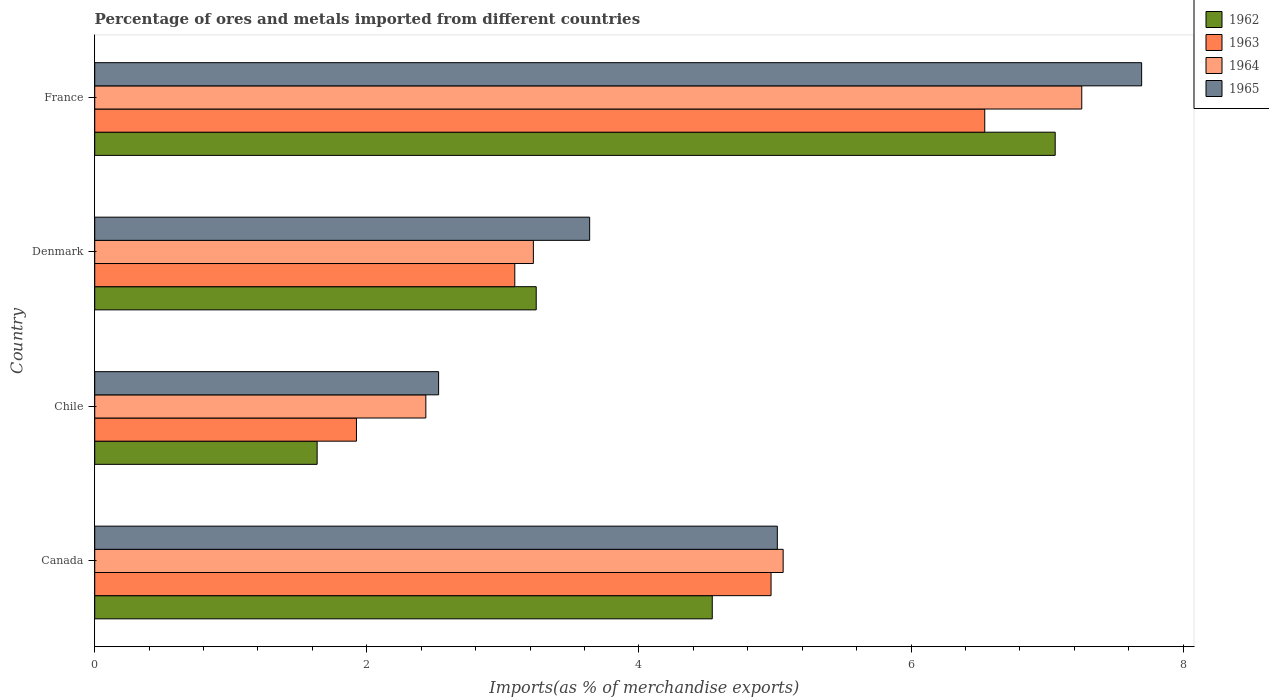How many different coloured bars are there?
Make the answer very short. 4. How many groups of bars are there?
Keep it short and to the point. 4. Are the number of bars per tick equal to the number of legend labels?
Offer a terse response. Yes. Are the number of bars on each tick of the Y-axis equal?
Offer a very short reply. Yes. How many bars are there on the 2nd tick from the top?
Your answer should be very brief. 4. What is the percentage of imports to different countries in 1963 in Denmark?
Give a very brief answer. 3.09. Across all countries, what is the maximum percentage of imports to different countries in 1962?
Your response must be concise. 7.06. Across all countries, what is the minimum percentage of imports to different countries in 1963?
Your answer should be very brief. 1.92. In which country was the percentage of imports to different countries in 1962 minimum?
Offer a terse response. Chile. What is the total percentage of imports to different countries in 1965 in the graph?
Make the answer very short. 18.88. What is the difference between the percentage of imports to different countries in 1964 in Chile and that in Denmark?
Keep it short and to the point. -0.79. What is the difference between the percentage of imports to different countries in 1962 in Chile and the percentage of imports to different countries in 1963 in Denmark?
Provide a short and direct response. -1.45. What is the average percentage of imports to different countries in 1963 per country?
Give a very brief answer. 4.13. What is the difference between the percentage of imports to different countries in 1964 and percentage of imports to different countries in 1965 in Canada?
Your answer should be very brief. 0.04. What is the ratio of the percentage of imports to different countries in 1965 in Canada to that in France?
Provide a short and direct response. 0.65. Is the percentage of imports to different countries in 1964 in Canada less than that in France?
Offer a terse response. Yes. What is the difference between the highest and the second highest percentage of imports to different countries in 1962?
Provide a short and direct response. 2.52. What is the difference between the highest and the lowest percentage of imports to different countries in 1963?
Give a very brief answer. 4.62. What does the 1st bar from the bottom in Canada represents?
Keep it short and to the point. 1962. Are all the bars in the graph horizontal?
Your answer should be very brief. Yes. Are the values on the major ticks of X-axis written in scientific E-notation?
Provide a succinct answer. No. What is the title of the graph?
Make the answer very short. Percentage of ores and metals imported from different countries. What is the label or title of the X-axis?
Provide a succinct answer. Imports(as % of merchandise exports). What is the label or title of the Y-axis?
Keep it short and to the point. Country. What is the Imports(as % of merchandise exports) in 1962 in Canada?
Offer a terse response. 4.54. What is the Imports(as % of merchandise exports) of 1963 in Canada?
Keep it short and to the point. 4.97. What is the Imports(as % of merchandise exports) of 1964 in Canada?
Offer a very short reply. 5.06. What is the Imports(as % of merchandise exports) of 1965 in Canada?
Keep it short and to the point. 5.02. What is the Imports(as % of merchandise exports) of 1962 in Chile?
Give a very brief answer. 1.63. What is the Imports(as % of merchandise exports) in 1963 in Chile?
Keep it short and to the point. 1.92. What is the Imports(as % of merchandise exports) in 1964 in Chile?
Your response must be concise. 2.43. What is the Imports(as % of merchandise exports) of 1965 in Chile?
Make the answer very short. 2.53. What is the Imports(as % of merchandise exports) in 1962 in Denmark?
Keep it short and to the point. 3.25. What is the Imports(as % of merchandise exports) in 1963 in Denmark?
Give a very brief answer. 3.09. What is the Imports(as % of merchandise exports) in 1964 in Denmark?
Your response must be concise. 3.22. What is the Imports(as % of merchandise exports) of 1965 in Denmark?
Your answer should be compact. 3.64. What is the Imports(as % of merchandise exports) in 1962 in France?
Keep it short and to the point. 7.06. What is the Imports(as % of merchandise exports) of 1963 in France?
Offer a very short reply. 6.54. What is the Imports(as % of merchandise exports) in 1964 in France?
Ensure brevity in your answer.  7.26. What is the Imports(as % of merchandise exports) in 1965 in France?
Provide a succinct answer. 7.7. Across all countries, what is the maximum Imports(as % of merchandise exports) in 1962?
Your response must be concise. 7.06. Across all countries, what is the maximum Imports(as % of merchandise exports) of 1963?
Your response must be concise. 6.54. Across all countries, what is the maximum Imports(as % of merchandise exports) of 1964?
Your answer should be compact. 7.26. Across all countries, what is the maximum Imports(as % of merchandise exports) in 1965?
Make the answer very short. 7.7. Across all countries, what is the minimum Imports(as % of merchandise exports) of 1962?
Provide a succinct answer. 1.63. Across all countries, what is the minimum Imports(as % of merchandise exports) of 1963?
Give a very brief answer. 1.92. Across all countries, what is the minimum Imports(as % of merchandise exports) of 1964?
Provide a short and direct response. 2.43. Across all countries, what is the minimum Imports(as % of merchandise exports) of 1965?
Offer a very short reply. 2.53. What is the total Imports(as % of merchandise exports) in 1962 in the graph?
Provide a short and direct response. 16.48. What is the total Imports(as % of merchandise exports) in 1963 in the graph?
Make the answer very short. 16.52. What is the total Imports(as % of merchandise exports) of 1964 in the graph?
Provide a short and direct response. 17.97. What is the total Imports(as % of merchandise exports) in 1965 in the graph?
Your answer should be very brief. 18.88. What is the difference between the Imports(as % of merchandise exports) of 1962 in Canada and that in Chile?
Keep it short and to the point. 2.9. What is the difference between the Imports(as % of merchandise exports) in 1963 in Canada and that in Chile?
Your answer should be very brief. 3.05. What is the difference between the Imports(as % of merchandise exports) of 1964 in Canada and that in Chile?
Offer a terse response. 2.63. What is the difference between the Imports(as % of merchandise exports) in 1965 in Canada and that in Chile?
Your answer should be very brief. 2.49. What is the difference between the Imports(as % of merchandise exports) in 1962 in Canada and that in Denmark?
Provide a succinct answer. 1.29. What is the difference between the Imports(as % of merchandise exports) of 1963 in Canada and that in Denmark?
Provide a succinct answer. 1.88. What is the difference between the Imports(as % of merchandise exports) of 1964 in Canada and that in Denmark?
Your response must be concise. 1.84. What is the difference between the Imports(as % of merchandise exports) in 1965 in Canada and that in Denmark?
Provide a succinct answer. 1.38. What is the difference between the Imports(as % of merchandise exports) in 1962 in Canada and that in France?
Give a very brief answer. -2.52. What is the difference between the Imports(as % of merchandise exports) of 1963 in Canada and that in France?
Offer a terse response. -1.57. What is the difference between the Imports(as % of merchandise exports) in 1964 in Canada and that in France?
Ensure brevity in your answer.  -2.19. What is the difference between the Imports(as % of merchandise exports) in 1965 in Canada and that in France?
Provide a short and direct response. -2.68. What is the difference between the Imports(as % of merchandise exports) in 1962 in Chile and that in Denmark?
Give a very brief answer. -1.61. What is the difference between the Imports(as % of merchandise exports) of 1963 in Chile and that in Denmark?
Ensure brevity in your answer.  -1.16. What is the difference between the Imports(as % of merchandise exports) in 1964 in Chile and that in Denmark?
Ensure brevity in your answer.  -0.79. What is the difference between the Imports(as % of merchandise exports) in 1965 in Chile and that in Denmark?
Give a very brief answer. -1.11. What is the difference between the Imports(as % of merchandise exports) in 1962 in Chile and that in France?
Ensure brevity in your answer.  -5.43. What is the difference between the Imports(as % of merchandise exports) of 1963 in Chile and that in France?
Your answer should be compact. -4.62. What is the difference between the Imports(as % of merchandise exports) of 1964 in Chile and that in France?
Give a very brief answer. -4.82. What is the difference between the Imports(as % of merchandise exports) of 1965 in Chile and that in France?
Your answer should be very brief. -5.17. What is the difference between the Imports(as % of merchandise exports) in 1962 in Denmark and that in France?
Ensure brevity in your answer.  -3.81. What is the difference between the Imports(as % of merchandise exports) of 1963 in Denmark and that in France?
Offer a terse response. -3.45. What is the difference between the Imports(as % of merchandise exports) in 1964 in Denmark and that in France?
Give a very brief answer. -4.03. What is the difference between the Imports(as % of merchandise exports) of 1965 in Denmark and that in France?
Give a very brief answer. -4.06. What is the difference between the Imports(as % of merchandise exports) in 1962 in Canada and the Imports(as % of merchandise exports) in 1963 in Chile?
Offer a very short reply. 2.62. What is the difference between the Imports(as % of merchandise exports) in 1962 in Canada and the Imports(as % of merchandise exports) in 1964 in Chile?
Your answer should be compact. 2.11. What is the difference between the Imports(as % of merchandise exports) in 1962 in Canada and the Imports(as % of merchandise exports) in 1965 in Chile?
Make the answer very short. 2.01. What is the difference between the Imports(as % of merchandise exports) of 1963 in Canada and the Imports(as % of merchandise exports) of 1964 in Chile?
Make the answer very short. 2.54. What is the difference between the Imports(as % of merchandise exports) of 1963 in Canada and the Imports(as % of merchandise exports) of 1965 in Chile?
Make the answer very short. 2.44. What is the difference between the Imports(as % of merchandise exports) of 1964 in Canada and the Imports(as % of merchandise exports) of 1965 in Chile?
Your answer should be compact. 2.53. What is the difference between the Imports(as % of merchandise exports) of 1962 in Canada and the Imports(as % of merchandise exports) of 1963 in Denmark?
Offer a terse response. 1.45. What is the difference between the Imports(as % of merchandise exports) of 1962 in Canada and the Imports(as % of merchandise exports) of 1964 in Denmark?
Keep it short and to the point. 1.31. What is the difference between the Imports(as % of merchandise exports) of 1962 in Canada and the Imports(as % of merchandise exports) of 1965 in Denmark?
Give a very brief answer. 0.9. What is the difference between the Imports(as % of merchandise exports) in 1963 in Canada and the Imports(as % of merchandise exports) in 1964 in Denmark?
Make the answer very short. 1.75. What is the difference between the Imports(as % of merchandise exports) of 1963 in Canada and the Imports(as % of merchandise exports) of 1965 in Denmark?
Make the answer very short. 1.33. What is the difference between the Imports(as % of merchandise exports) in 1964 in Canada and the Imports(as % of merchandise exports) in 1965 in Denmark?
Offer a very short reply. 1.42. What is the difference between the Imports(as % of merchandise exports) in 1962 in Canada and the Imports(as % of merchandise exports) in 1963 in France?
Provide a short and direct response. -2. What is the difference between the Imports(as % of merchandise exports) in 1962 in Canada and the Imports(as % of merchandise exports) in 1964 in France?
Ensure brevity in your answer.  -2.72. What is the difference between the Imports(as % of merchandise exports) of 1962 in Canada and the Imports(as % of merchandise exports) of 1965 in France?
Make the answer very short. -3.16. What is the difference between the Imports(as % of merchandise exports) in 1963 in Canada and the Imports(as % of merchandise exports) in 1964 in France?
Provide a short and direct response. -2.28. What is the difference between the Imports(as % of merchandise exports) of 1963 in Canada and the Imports(as % of merchandise exports) of 1965 in France?
Keep it short and to the point. -2.72. What is the difference between the Imports(as % of merchandise exports) in 1964 in Canada and the Imports(as % of merchandise exports) in 1965 in France?
Your answer should be very brief. -2.64. What is the difference between the Imports(as % of merchandise exports) in 1962 in Chile and the Imports(as % of merchandise exports) in 1963 in Denmark?
Give a very brief answer. -1.45. What is the difference between the Imports(as % of merchandise exports) of 1962 in Chile and the Imports(as % of merchandise exports) of 1964 in Denmark?
Your response must be concise. -1.59. What is the difference between the Imports(as % of merchandise exports) in 1962 in Chile and the Imports(as % of merchandise exports) in 1965 in Denmark?
Give a very brief answer. -2. What is the difference between the Imports(as % of merchandise exports) of 1963 in Chile and the Imports(as % of merchandise exports) of 1964 in Denmark?
Give a very brief answer. -1.3. What is the difference between the Imports(as % of merchandise exports) of 1963 in Chile and the Imports(as % of merchandise exports) of 1965 in Denmark?
Your response must be concise. -1.71. What is the difference between the Imports(as % of merchandise exports) of 1964 in Chile and the Imports(as % of merchandise exports) of 1965 in Denmark?
Offer a terse response. -1.2. What is the difference between the Imports(as % of merchandise exports) in 1962 in Chile and the Imports(as % of merchandise exports) in 1963 in France?
Provide a short and direct response. -4.91. What is the difference between the Imports(as % of merchandise exports) in 1962 in Chile and the Imports(as % of merchandise exports) in 1964 in France?
Provide a succinct answer. -5.62. What is the difference between the Imports(as % of merchandise exports) in 1962 in Chile and the Imports(as % of merchandise exports) in 1965 in France?
Offer a very short reply. -6.06. What is the difference between the Imports(as % of merchandise exports) in 1963 in Chile and the Imports(as % of merchandise exports) in 1964 in France?
Offer a very short reply. -5.33. What is the difference between the Imports(as % of merchandise exports) in 1963 in Chile and the Imports(as % of merchandise exports) in 1965 in France?
Keep it short and to the point. -5.77. What is the difference between the Imports(as % of merchandise exports) in 1964 in Chile and the Imports(as % of merchandise exports) in 1965 in France?
Make the answer very short. -5.26. What is the difference between the Imports(as % of merchandise exports) of 1962 in Denmark and the Imports(as % of merchandise exports) of 1963 in France?
Provide a succinct answer. -3.3. What is the difference between the Imports(as % of merchandise exports) of 1962 in Denmark and the Imports(as % of merchandise exports) of 1964 in France?
Provide a short and direct response. -4.01. What is the difference between the Imports(as % of merchandise exports) in 1962 in Denmark and the Imports(as % of merchandise exports) in 1965 in France?
Ensure brevity in your answer.  -4.45. What is the difference between the Imports(as % of merchandise exports) in 1963 in Denmark and the Imports(as % of merchandise exports) in 1964 in France?
Keep it short and to the point. -4.17. What is the difference between the Imports(as % of merchandise exports) in 1963 in Denmark and the Imports(as % of merchandise exports) in 1965 in France?
Provide a short and direct response. -4.61. What is the difference between the Imports(as % of merchandise exports) of 1964 in Denmark and the Imports(as % of merchandise exports) of 1965 in France?
Ensure brevity in your answer.  -4.47. What is the average Imports(as % of merchandise exports) in 1962 per country?
Your answer should be very brief. 4.12. What is the average Imports(as % of merchandise exports) of 1963 per country?
Provide a short and direct response. 4.13. What is the average Imports(as % of merchandise exports) of 1964 per country?
Ensure brevity in your answer.  4.49. What is the average Imports(as % of merchandise exports) of 1965 per country?
Your answer should be compact. 4.72. What is the difference between the Imports(as % of merchandise exports) of 1962 and Imports(as % of merchandise exports) of 1963 in Canada?
Give a very brief answer. -0.43. What is the difference between the Imports(as % of merchandise exports) of 1962 and Imports(as % of merchandise exports) of 1964 in Canada?
Your answer should be compact. -0.52. What is the difference between the Imports(as % of merchandise exports) in 1962 and Imports(as % of merchandise exports) in 1965 in Canada?
Keep it short and to the point. -0.48. What is the difference between the Imports(as % of merchandise exports) in 1963 and Imports(as % of merchandise exports) in 1964 in Canada?
Provide a succinct answer. -0.09. What is the difference between the Imports(as % of merchandise exports) in 1963 and Imports(as % of merchandise exports) in 1965 in Canada?
Give a very brief answer. -0.05. What is the difference between the Imports(as % of merchandise exports) in 1964 and Imports(as % of merchandise exports) in 1965 in Canada?
Provide a short and direct response. 0.04. What is the difference between the Imports(as % of merchandise exports) of 1962 and Imports(as % of merchandise exports) of 1963 in Chile?
Keep it short and to the point. -0.29. What is the difference between the Imports(as % of merchandise exports) in 1962 and Imports(as % of merchandise exports) in 1964 in Chile?
Keep it short and to the point. -0.8. What is the difference between the Imports(as % of merchandise exports) of 1962 and Imports(as % of merchandise exports) of 1965 in Chile?
Ensure brevity in your answer.  -0.89. What is the difference between the Imports(as % of merchandise exports) of 1963 and Imports(as % of merchandise exports) of 1964 in Chile?
Offer a very short reply. -0.51. What is the difference between the Imports(as % of merchandise exports) in 1963 and Imports(as % of merchandise exports) in 1965 in Chile?
Your answer should be very brief. -0.6. What is the difference between the Imports(as % of merchandise exports) of 1964 and Imports(as % of merchandise exports) of 1965 in Chile?
Provide a succinct answer. -0.09. What is the difference between the Imports(as % of merchandise exports) in 1962 and Imports(as % of merchandise exports) in 1963 in Denmark?
Offer a terse response. 0.16. What is the difference between the Imports(as % of merchandise exports) in 1962 and Imports(as % of merchandise exports) in 1964 in Denmark?
Your answer should be very brief. 0.02. What is the difference between the Imports(as % of merchandise exports) in 1962 and Imports(as % of merchandise exports) in 1965 in Denmark?
Offer a terse response. -0.39. What is the difference between the Imports(as % of merchandise exports) in 1963 and Imports(as % of merchandise exports) in 1964 in Denmark?
Offer a very short reply. -0.14. What is the difference between the Imports(as % of merchandise exports) of 1963 and Imports(as % of merchandise exports) of 1965 in Denmark?
Give a very brief answer. -0.55. What is the difference between the Imports(as % of merchandise exports) of 1964 and Imports(as % of merchandise exports) of 1965 in Denmark?
Your answer should be compact. -0.41. What is the difference between the Imports(as % of merchandise exports) in 1962 and Imports(as % of merchandise exports) in 1963 in France?
Provide a succinct answer. 0.52. What is the difference between the Imports(as % of merchandise exports) in 1962 and Imports(as % of merchandise exports) in 1964 in France?
Keep it short and to the point. -0.2. What is the difference between the Imports(as % of merchandise exports) in 1962 and Imports(as % of merchandise exports) in 1965 in France?
Keep it short and to the point. -0.64. What is the difference between the Imports(as % of merchandise exports) of 1963 and Imports(as % of merchandise exports) of 1964 in France?
Offer a terse response. -0.71. What is the difference between the Imports(as % of merchandise exports) of 1963 and Imports(as % of merchandise exports) of 1965 in France?
Ensure brevity in your answer.  -1.15. What is the difference between the Imports(as % of merchandise exports) in 1964 and Imports(as % of merchandise exports) in 1965 in France?
Give a very brief answer. -0.44. What is the ratio of the Imports(as % of merchandise exports) of 1962 in Canada to that in Chile?
Provide a succinct answer. 2.78. What is the ratio of the Imports(as % of merchandise exports) in 1963 in Canada to that in Chile?
Offer a terse response. 2.58. What is the ratio of the Imports(as % of merchandise exports) of 1964 in Canada to that in Chile?
Provide a short and direct response. 2.08. What is the ratio of the Imports(as % of merchandise exports) of 1965 in Canada to that in Chile?
Provide a succinct answer. 1.99. What is the ratio of the Imports(as % of merchandise exports) of 1962 in Canada to that in Denmark?
Ensure brevity in your answer.  1.4. What is the ratio of the Imports(as % of merchandise exports) in 1963 in Canada to that in Denmark?
Keep it short and to the point. 1.61. What is the ratio of the Imports(as % of merchandise exports) in 1964 in Canada to that in Denmark?
Provide a succinct answer. 1.57. What is the ratio of the Imports(as % of merchandise exports) of 1965 in Canada to that in Denmark?
Ensure brevity in your answer.  1.38. What is the ratio of the Imports(as % of merchandise exports) of 1962 in Canada to that in France?
Offer a very short reply. 0.64. What is the ratio of the Imports(as % of merchandise exports) of 1963 in Canada to that in France?
Give a very brief answer. 0.76. What is the ratio of the Imports(as % of merchandise exports) of 1964 in Canada to that in France?
Make the answer very short. 0.7. What is the ratio of the Imports(as % of merchandise exports) of 1965 in Canada to that in France?
Make the answer very short. 0.65. What is the ratio of the Imports(as % of merchandise exports) in 1962 in Chile to that in Denmark?
Provide a succinct answer. 0.5. What is the ratio of the Imports(as % of merchandise exports) in 1963 in Chile to that in Denmark?
Offer a terse response. 0.62. What is the ratio of the Imports(as % of merchandise exports) of 1964 in Chile to that in Denmark?
Your answer should be very brief. 0.75. What is the ratio of the Imports(as % of merchandise exports) in 1965 in Chile to that in Denmark?
Offer a terse response. 0.69. What is the ratio of the Imports(as % of merchandise exports) in 1962 in Chile to that in France?
Ensure brevity in your answer.  0.23. What is the ratio of the Imports(as % of merchandise exports) of 1963 in Chile to that in France?
Offer a very short reply. 0.29. What is the ratio of the Imports(as % of merchandise exports) of 1964 in Chile to that in France?
Your answer should be very brief. 0.34. What is the ratio of the Imports(as % of merchandise exports) of 1965 in Chile to that in France?
Keep it short and to the point. 0.33. What is the ratio of the Imports(as % of merchandise exports) of 1962 in Denmark to that in France?
Ensure brevity in your answer.  0.46. What is the ratio of the Imports(as % of merchandise exports) of 1963 in Denmark to that in France?
Provide a succinct answer. 0.47. What is the ratio of the Imports(as % of merchandise exports) in 1964 in Denmark to that in France?
Make the answer very short. 0.44. What is the ratio of the Imports(as % of merchandise exports) in 1965 in Denmark to that in France?
Provide a short and direct response. 0.47. What is the difference between the highest and the second highest Imports(as % of merchandise exports) in 1962?
Provide a short and direct response. 2.52. What is the difference between the highest and the second highest Imports(as % of merchandise exports) of 1963?
Keep it short and to the point. 1.57. What is the difference between the highest and the second highest Imports(as % of merchandise exports) of 1964?
Provide a short and direct response. 2.19. What is the difference between the highest and the second highest Imports(as % of merchandise exports) of 1965?
Provide a succinct answer. 2.68. What is the difference between the highest and the lowest Imports(as % of merchandise exports) of 1962?
Give a very brief answer. 5.43. What is the difference between the highest and the lowest Imports(as % of merchandise exports) in 1963?
Offer a terse response. 4.62. What is the difference between the highest and the lowest Imports(as % of merchandise exports) of 1964?
Give a very brief answer. 4.82. What is the difference between the highest and the lowest Imports(as % of merchandise exports) in 1965?
Offer a terse response. 5.17. 